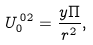<formula> <loc_0><loc_0><loc_500><loc_500>U _ { 0 } ^ { \, 0 2 } = \frac { y \Pi } { r ^ { 2 } } ,</formula> 